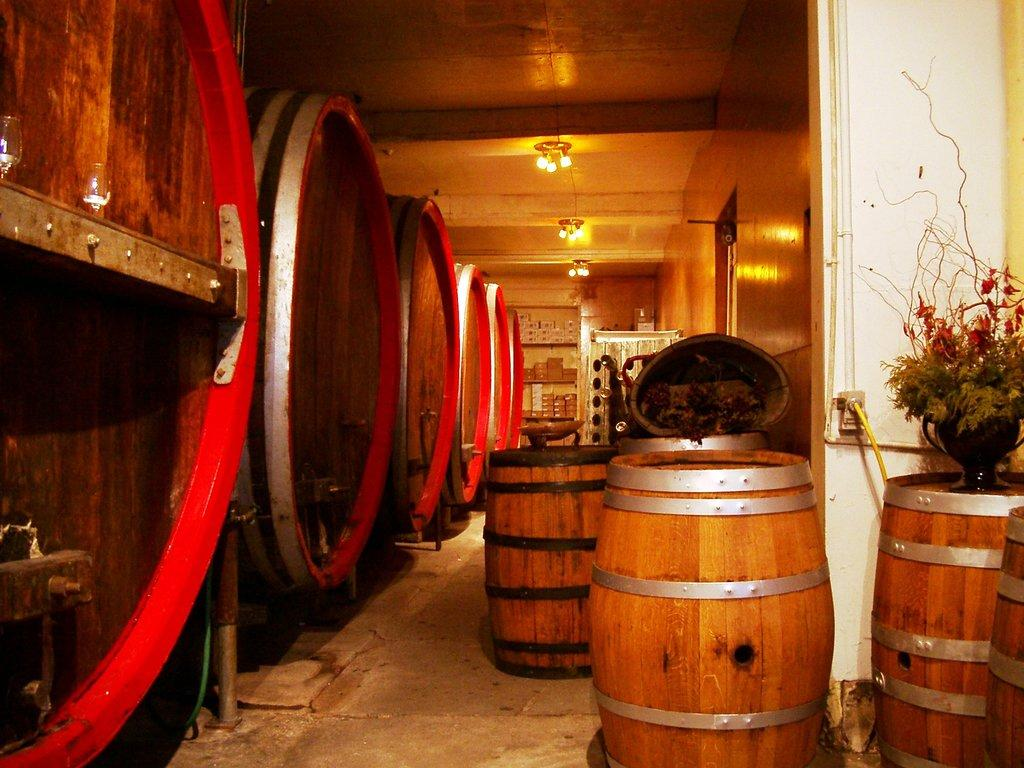What objects are present in the image? There are barrels in the image. Are there any additional features on the barrels? Yes, there is a plant on one of the barrels. What can be seen on the ceiling in the image? There are lights on the ceiling in the image. What type of joke is the writer telling in the image? There is no writer or joke present in the image; it features barrels, a plant, and lights on the ceiling. 